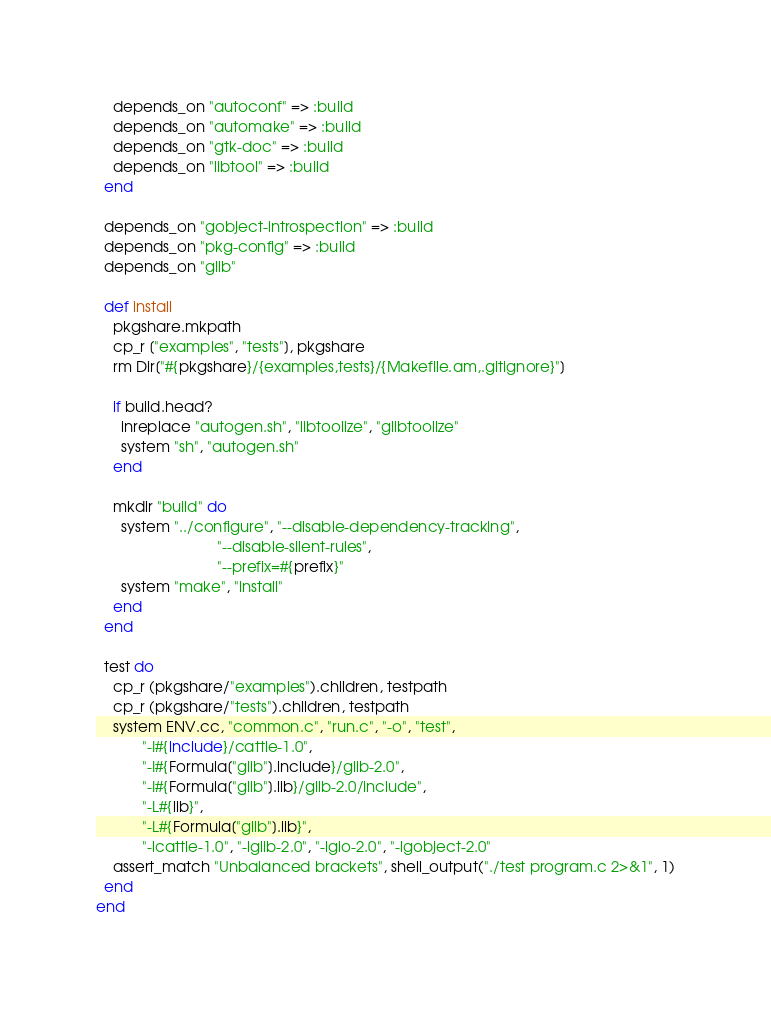<code> <loc_0><loc_0><loc_500><loc_500><_Ruby_>    depends_on "autoconf" => :build
    depends_on "automake" => :build
    depends_on "gtk-doc" => :build
    depends_on "libtool" => :build
  end

  depends_on "gobject-introspection" => :build
  depends_on "pkg-config" => :build
  depends_on "glib"

  def install
    pkgshare.mkpath
    cp_r ["examples", "tests"], pkgshare
    rm Dir["#{pkgshare}/{examples,tests}/{Makefile.am,.gitignore}"]

    if build.head?
      inreplace "autogen.sh", "libtoolize", "glibtoolize"
      system "sh", "autogen.sh"
    end

    mkdir "build" do
      system "../configure", "--disable-dependency-tracking",
                             "--disable-silent-rules",
                             "--prefix=#{prefix}"
      system "make", "install"
    end
  end

  test do
    cp_r (pkgshare/"examples").children, testpath
    cp_r (pkgshare/"tests").children, testpath
    system ENV.cc, "common.c", "run.c", "-o", "test",
           "-I#{include}/cattle-1.0",
           "-I#{Formula["glib"].include}/glib-2.0",
           "-I#{Formula["glib"].lib}/glib-2.0/include",
           "-L#{lib}",
           "-L#{Formula["glib"].lib}",
           "-lcattle-1.0", "-lglib-2.0", "-lgio-2.0", "-lgobject-2.0"
    assert_match "Unbalanced brackets", shell_output("./test program.c 2>&1", 1)
  end
end
</code> 